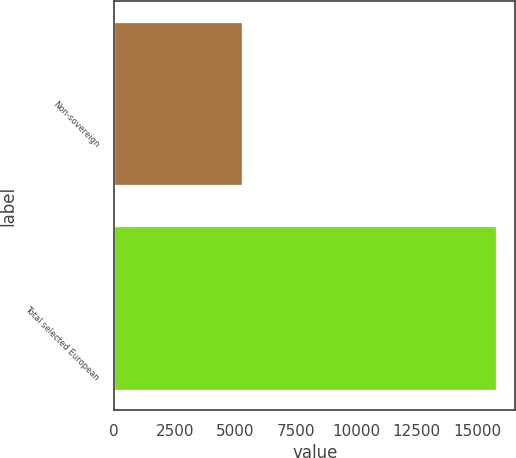Convert chart to OTSL. <chart><loc_0><loc_0><loc_500><loc_500><bar_chart><fcel>Non-sovereign<fcel>Total selected European<nl><fcel>5268<fcel>15789<nl></chart> 